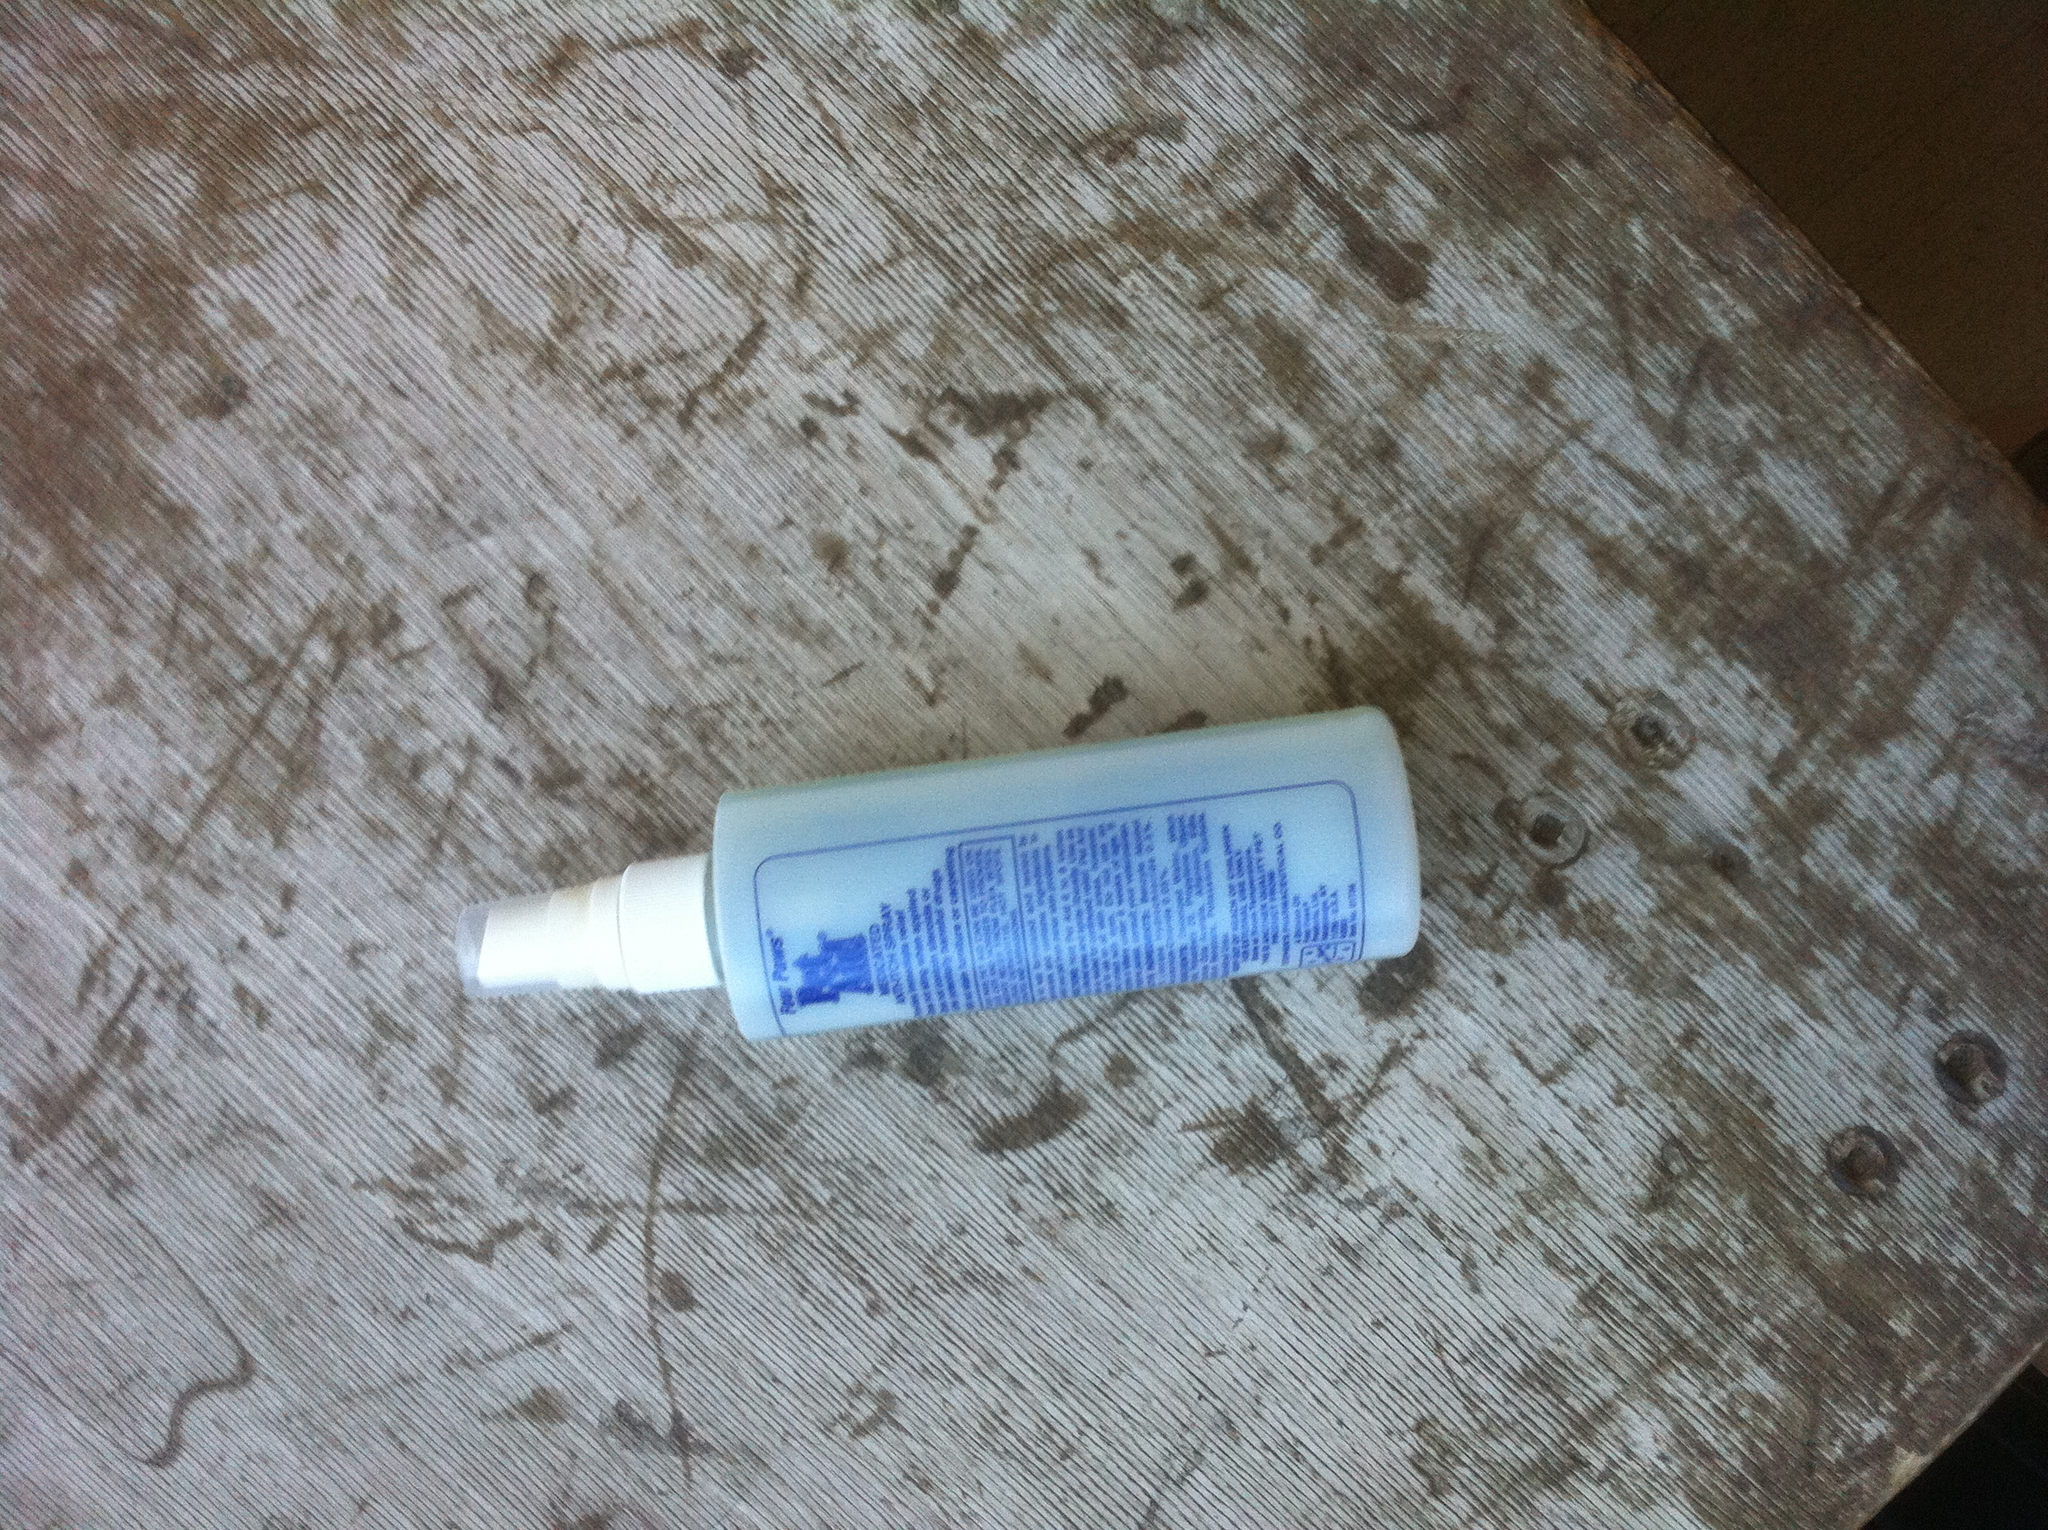Can you read any specific instructions or ingredients listed on the label? The text on the label is not completely legible in the image provided. It appears to list ingredients and potentially usage instructions, but the small type and angle make it difficult to read the details clearly without a closer or more focused image. 